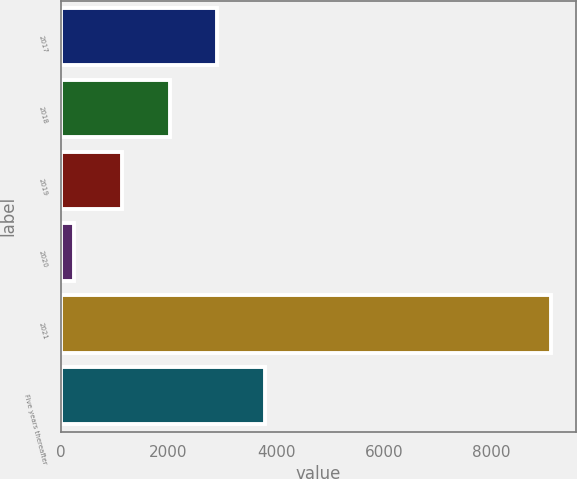Convert chart to OTSL. <chart><loc_0><loc_0><loc_500><loc_500><bar_chart><fcel>2017<fcel>2018<fcel>2019<fcel>2020<fcel>2021<fcel>Five years thereafter<nl><fcel>2911<fcel>2025<fcel>1139<fcel>253<fcel>9113<fcel>3797<nl></chart> 